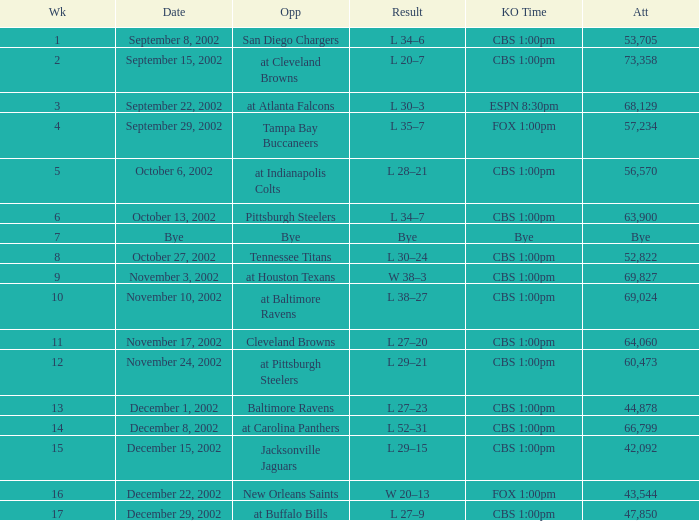What week number was the kickoff time cbs 1:00pm, with 60,473 people in attendance? 1.0. 